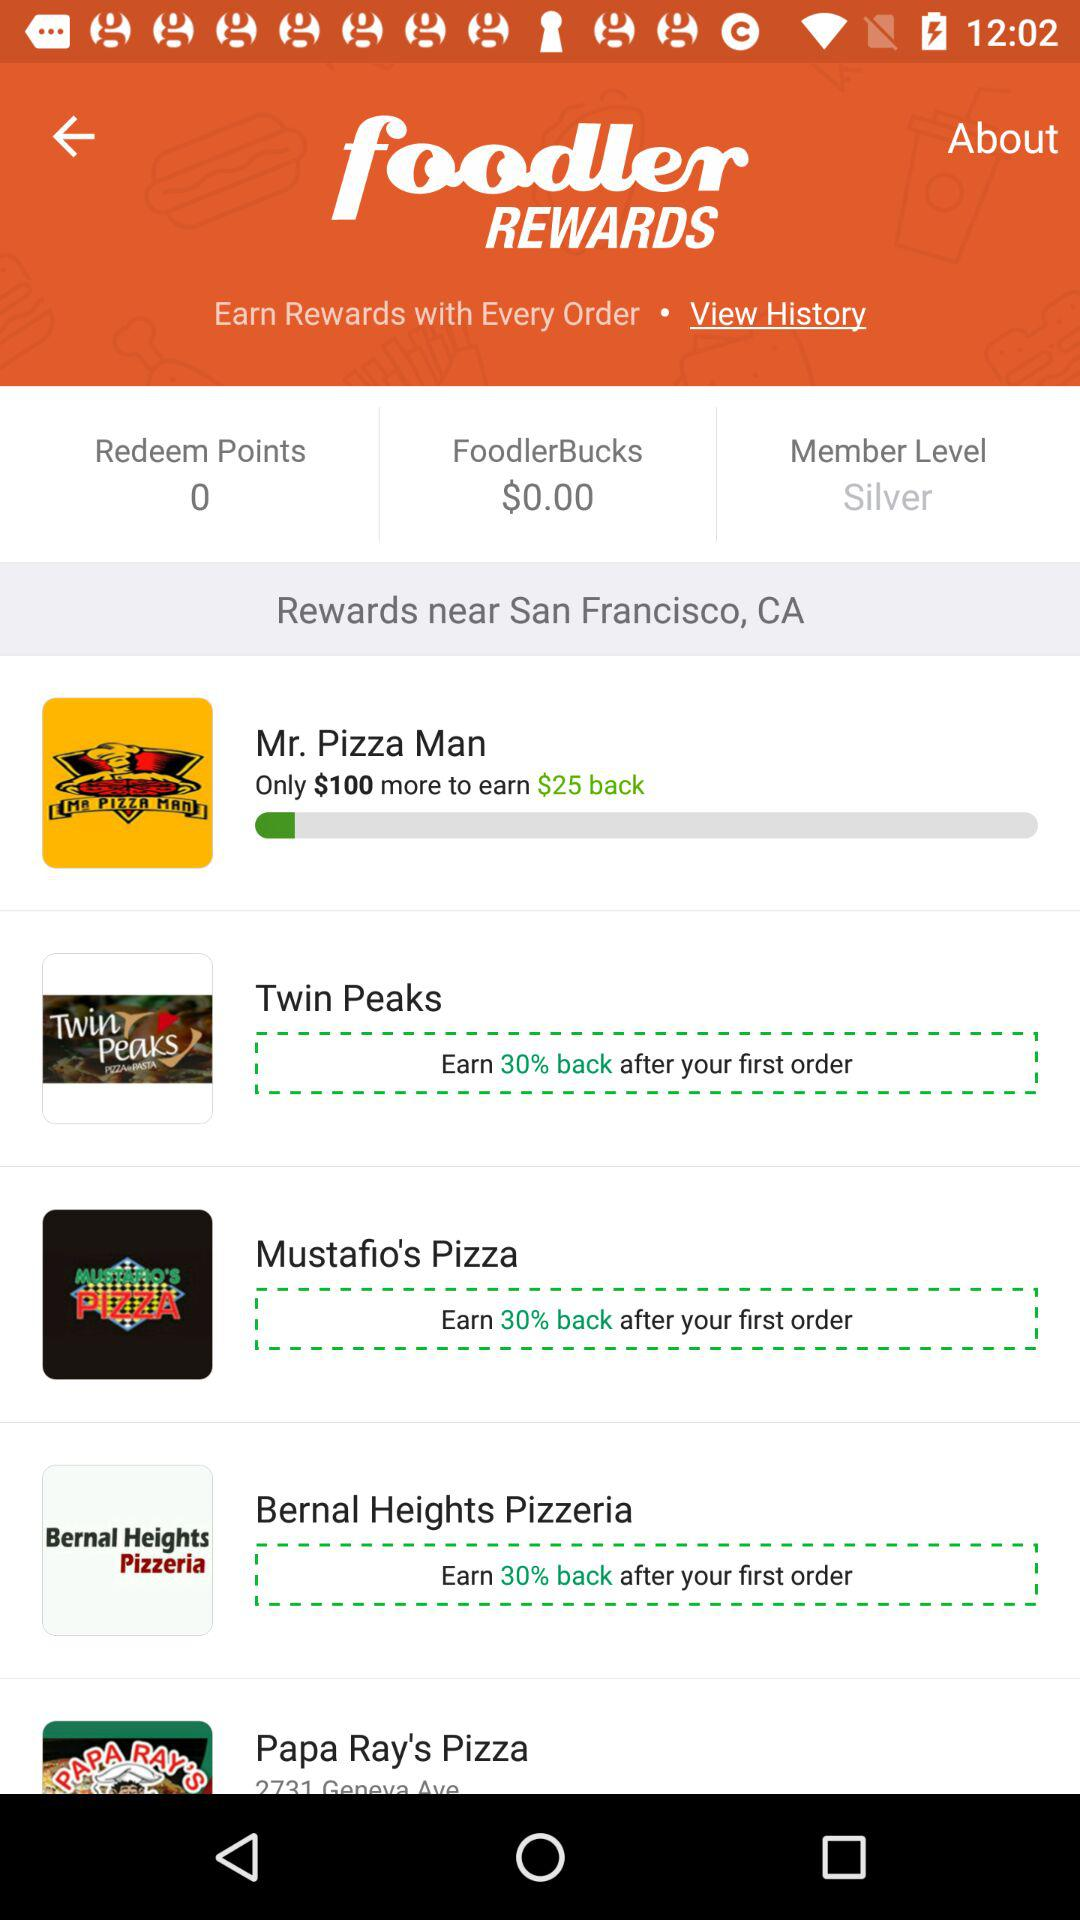Who is this application powered by?
When the provided information is insufficient, respond with <no answer>. <no answer> 